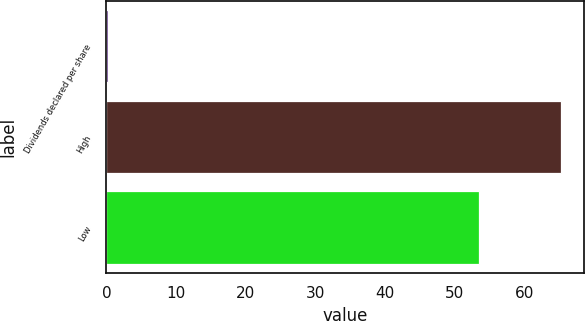<chart> <loc_0><loc_0><loc_500><loc_500><bar_chart><fcel>Dividends declared per share<fcel>High<fcel>Low<nl><fcel>0.18<fcel>65.2<fcel>53.5<nl></chart> 